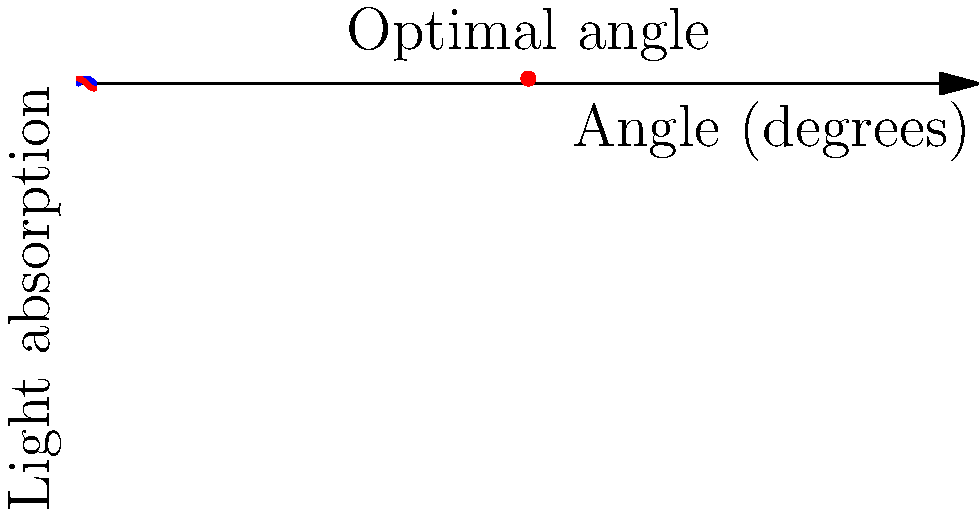Based on the graph showing leaf light absorption (blue) and sun position (red) over different angles, what is the optimal angle for plant leaves to maximize sunlight absorption? To determine the optimal angle for plant leaves to maximize sunlight absorption, we need to analyze the graph:

1. The blue curve represents leaf absorption, which follows a sine function.
2. The red curve represents sun position, which follows a cosine function.
3. The optimal angle occurs where these two curves intersect at their highest point.
4. This intersection happens at 90 degrees, as indicated by the labeled point on the graph.
5. At 90 degrees:
   - The leaf absorption is at its maximum (sin(90°) = 1)
   - The sun position is also optimal (cos(90°) = 0, meaning the sun is directly overhead)
6. This angle ensures that the leaf surface is perpendicular to the incoming sunlight, maximizing absorption.

The 90-degree angle represents leaves that are horizontal, which is ideal for capturing sunlight when the sun is directly overhead (e.g., at noon in many locations).
Answer: 90 degrees 